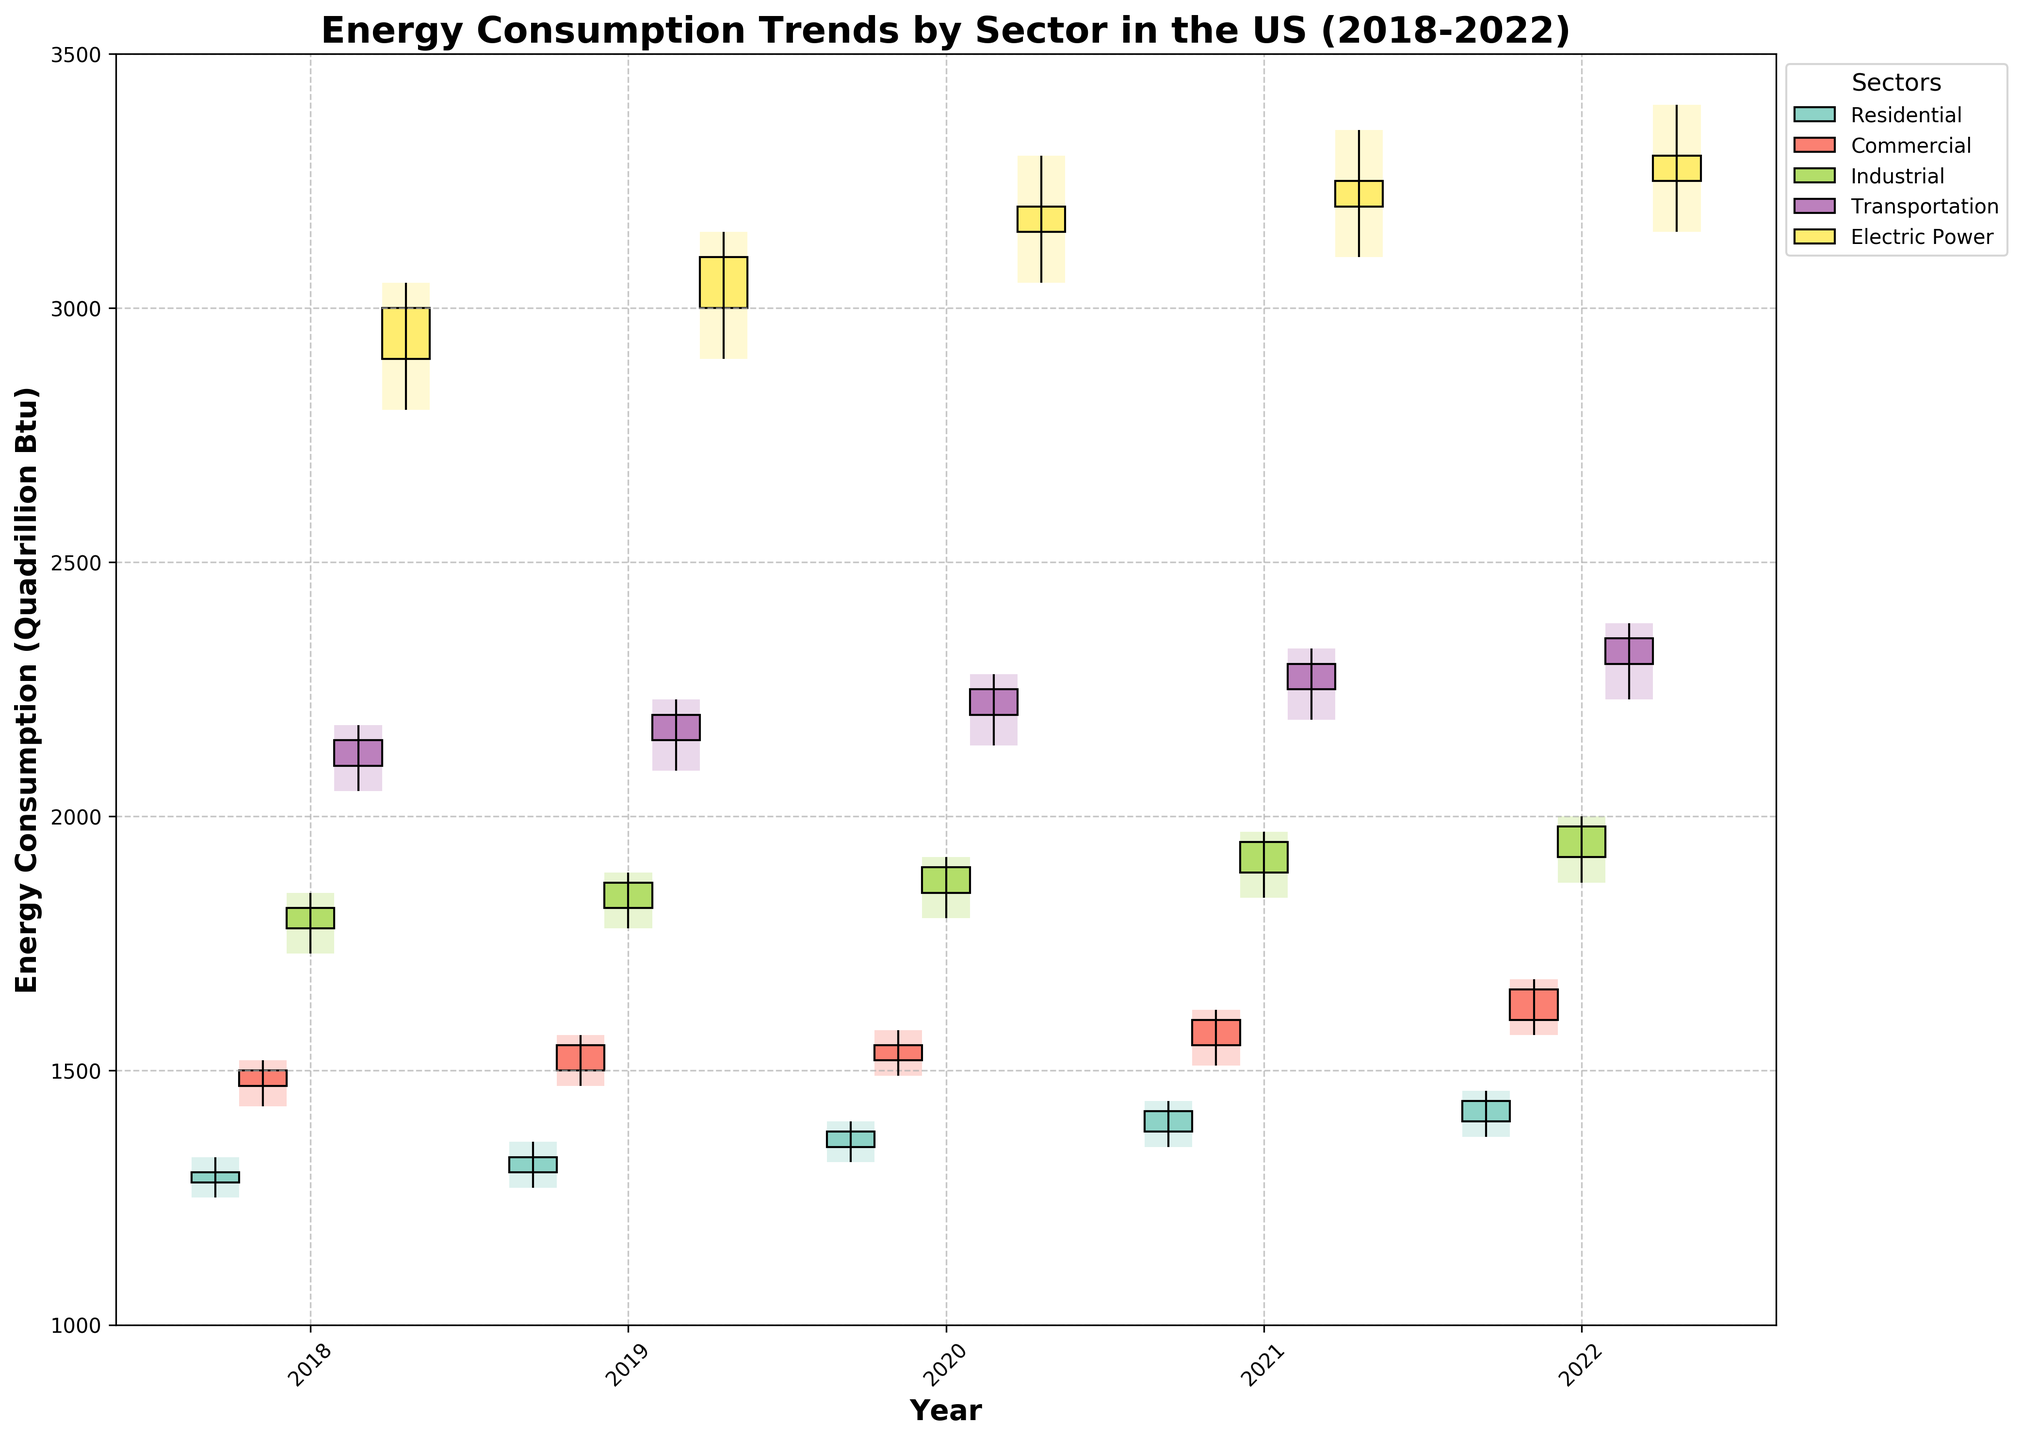What is the title of the figure? The title is usually found at the top of the figure. In this case, it is clearly shown above the plot.
Answer: Energy Consumption Trends by Sector in the US (2018-2022) How many tick marks are there on the x-axis? The x-axis shows the years, and there are labels for each year from 2018 to 2022. Count the labeled tick marks.
Answer: 5 Which sector had the highest energy consumption in 2022? Look for the bar which reaches the highest point in the 2022 section of the candlestick plot.
Answer: Electric Power In which year did the Residential sector show the highest opening energy consumption? For the Residential sector, compare the "Open" values across all years (2018-2022) to find the highest one.
Answer: 2022 What is the difference between the high and low values for the Industrial sector in 2021? Subtract the low value from the high value for the Industrial sector in 2021. The high is 1970 and the low is 1840.
Answer: 130 Which sector had the smallest range of energy consumption in 2019? Find the difference between the high and low values (range) for each sector in 2019, then compare these ranges.
Answer: Residential (90) Did the Commercial sector's energy consumption increase or decrease from 2021 to 2022? Compare the closing value of the Commercial sector in 2021 and 2022. The value increased from 1600 to 1660.
Answer: Increase How does the highest energy consumption in the Transportation sector in 2018 compare to the highest in 2020? Compare the "High" values for the Transportation sector in 2018 and 2020. In 2018 it's 2180 and in 2020 it's 2280.
Answer: The 2020 high is greater Which year had the smallest closing value for the Electric Power sector? Check the "Close" values for the Electric Power sector across all years, and identify the smallest one.
Answer: 2018 What is the average closing value for the Residential sector over the 5-year period? Sum the closing values of the Residential sector from each year (1300, 1330, 1380, 1420, 1440) and divide by 5.
Answer: 1374 